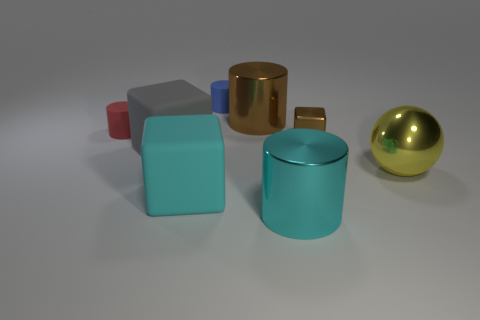Subtract all large cyan cylinders. How many cylinders are left? 3 Subtract all red cylinders. How many cylinders are left? 3 Add 2 green rubber balls. How many objects exist? 10 Subtract all yellow cylinders. Subtract all cyan spheres. How many cylinders are left? 4 Subtract all purple metallic cylinders. Subtract all red cylinders. How many objects are left? 7 Add 3 big shiny things. How many big shiny things are left? 6 Add 3 tiny objects. How many tiny objects exist? 6 Subtract 1 cyan blocks. How many objects are left? 7 Subtract all cubes. How many objects are left? 5 